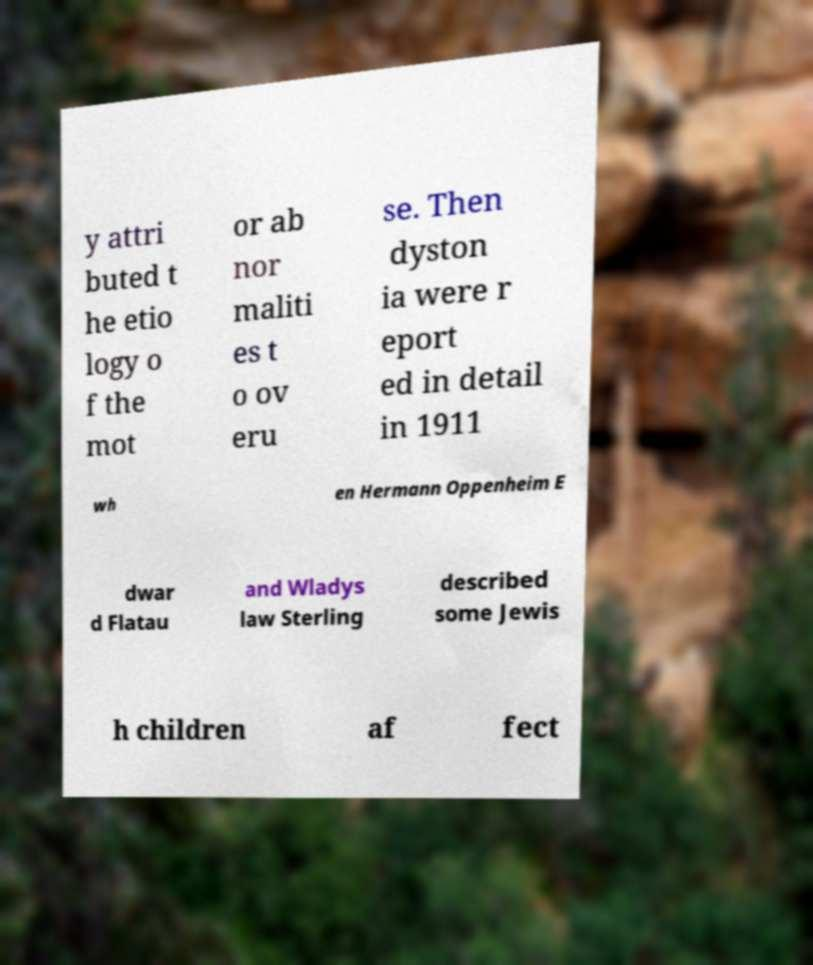For documentation purposes, I need the text within this image transcribed. Could you provide that? y attri buted t he etio logy o f the mot or ab nor maliti es t o ov eru se. Then dyston ia were r eport ed in detail in 1911 wh en Hermann Oppenheim E dwar d Flatau and Wladys law Sterling described some Jewis h children af fect 